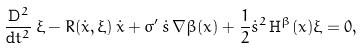<formula> <loc_0><loc_0><loc_500><loc_500>\frac { \mathrm D ^ { 2 } } { \mathrm d t ^ { 2 } } \, \xi - R ( \dot { x } , \xi ) \, \dot { x } + \sigma ^ { \prime } \, \dot { s } \, \nabla \beta ( x ) + \frac { 1 } { 2 } \dot { s } ^ { 2 } \, \mathrm H ^ { \beta } ( x ) \xi = 0 ,</formula> 